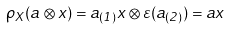Convert formula to latex. <formula><loc_0><loc_0><loc_500><loc_500>\rho _ { X } ( a \otimes x ) = a _ { ( 1 ) } x \otimes \varepsilon ( a _ { ( 2 ) } ) = a x</formula> 